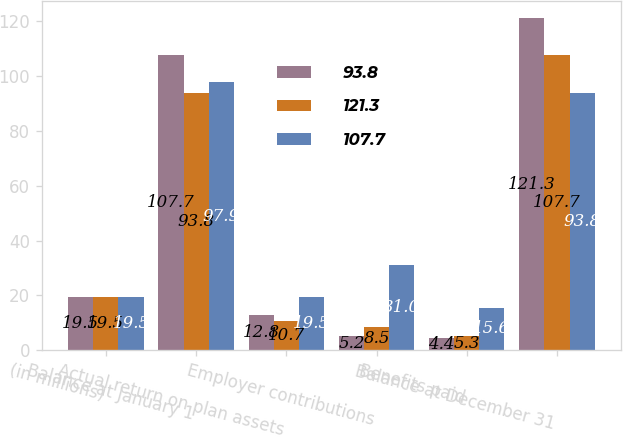Convert chart to OTSL. <chart><loc_0><loc_0><loc_500><loc_500><stacked_bar_chart><ecel><fcel>(in millions)<fcel>Balance at January 1<fcel>Actual return on plan assets<fcel>Employer contributions<fcel>Benefits paid<fcel>Balance at December 31<nl><fcel>93.8<fcel>19.5<fcel>107.7<fcel>12.8<fcel>5.2<fcel>4.4<fcel>121.3<nl><fcel>121.3<fcel>19.5<fcel>93.8<fcel>10.7<fcel>8.5<fcel>5.3<fcel>107.7<nl><fcel>107.7<fcel>19.5<fcel>97.9<fcel>19.5<fcel>31<fcel>15.6<fcel>93.8<nl></chart> 